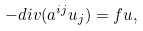Convert formula to latex. <formula><loc_0><loc_0><loc_500><loc_500>- d i v ( a ^ { i j } u _ { j } ) = f u ,</formula> 